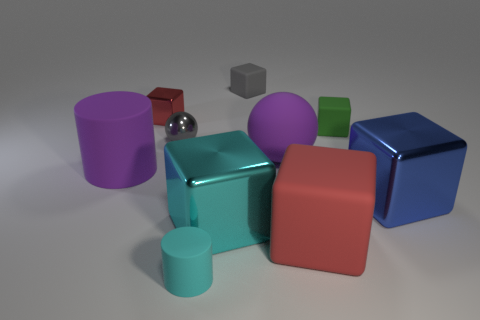What material is the big cylinder that is the same color as the big matte ball?
Give a very brief answer. Rubber. The purple rubber object to the right of the metallic object that is behind the small thing on the right side of the gray rubber object is what shape?
Ensure brevity in your answer.  Sphere. What number of other things are there of the same material as the cyan cylinder
Keep it short and to the point. 5. What number of things are purple matte things left of the gray rubber cube or small gray objects?
Give a very brief answer. 3. There is a red thing left of the sphere that is on the left side of the big cyan block; what shape is it?
Make the answer very short. Cube. There is a gray thing behind the green block; does it have the same shape as the cyan shiny object?
Your answer should be very brief. Yes. There is a matte thing that is to the left of the tiny matte cylinder; what color is it?
Your answer should be very brief. Purple. What number of cubes are either yellow rubber things or gray metal objects?
Give a very brief answer. 0. What size is the rubber block that is behind the tiny object that is right of the big red thing?
Offer a very short reply. Small. Does the small cylinder have the same color as the large shiny cube that is on the left side of the big blue shiny block?
Make the answer very short. Yes. 